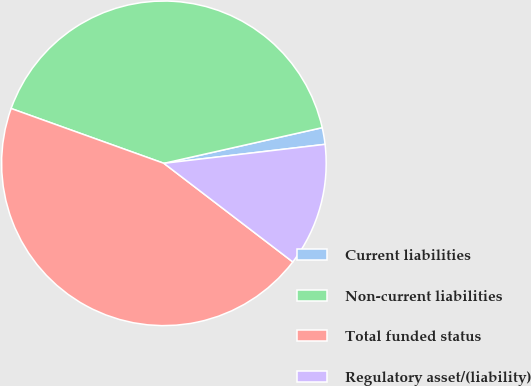<chart> <loc_0><loc_0><loc_500><loc_500><pie_chart><fcel>Current liabilities<fcel>Non-current liabilities<fcel>Total funded status<fcel>Regulatory asset/(liability)<nl><fcel>1.66%<fcel>40.99%<fcel>45.09%<fcel>12.26%<nl></chart> 